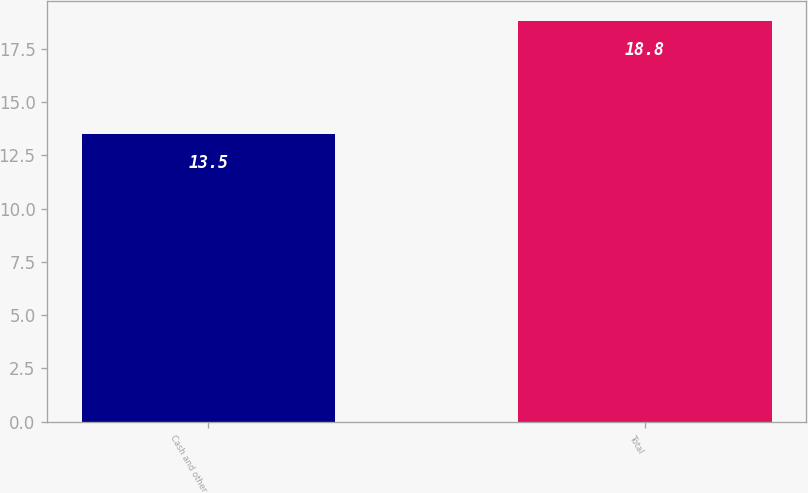<chart> <loc_0><loc_0><loc_500><loc_500><bar_chart><fcel>Cash and other<fcel>Total<nl><fcel>13.5<fcel>18.8<nl></chart> 